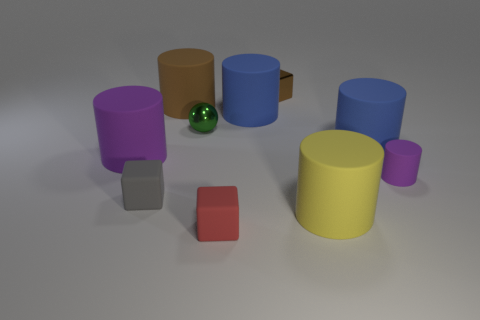Subtract all purple cylinders. How many cylinders are left? 4 Subtract 3 cylinders. How many cylinders are left? 3 Subtract all large purple rubber cylinders. How many cylinders are left? 5 Subtract all brown cylinders. Subtract all cyan blocks. How many cylinders are left? 5 Subtract all balls. How many objects are left? 9 Subtract 0 yellow cubes. How many objects are left? 10 Subtract all rubber objects. Subtract all big blue cylinders. How many objects are left? 0 Add 7 cubes. How many cubes are left? 10 Add 8 tiny shiny blocks. How many tiny shiny blocks exist? 9 